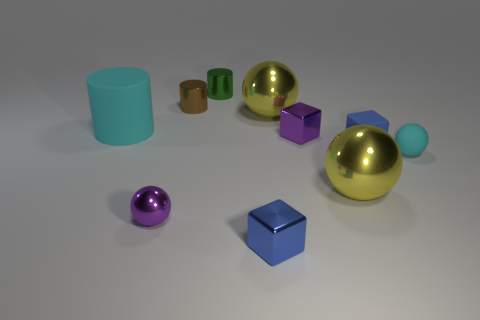Is there a small green shiny object that has the same shape as the big cyan object?
Ensure brevity in your answer.  Yes. How many objects are large cyan things or cyan objects right of the brown metallic object?
Give a very brief answer. 2. There is a sphere that is left of the green metallic cylinder; what is its color?
Keep it short and to the point. Purple. There is a cyan thing that is on the left side of the brown object; is it the same size as the yellow metal thing that is in front of the blue matte cube?
Your answer should be compact. Yes. Are there any yellow balls of the same size as the cyan cylinder?
Give a very brief answer. Yes. What number of large metal things are in front of the large yellow metallic sphere that is behind the small cyan rubber thing?
Give a very brief answer. 1. What is the material of the cyan ball?
Provide a succinct answer. Rubber. How many tiny brown cylinders are in front of the blue matte cube?
Provide a succinct answer. 0. Does the large cylinder have the same color as the matte ball?
Keep it short and to the point. Yes. How many big matte cylinders are the same color as the tiny matte sphere?
Offer a very short reply. 1. 